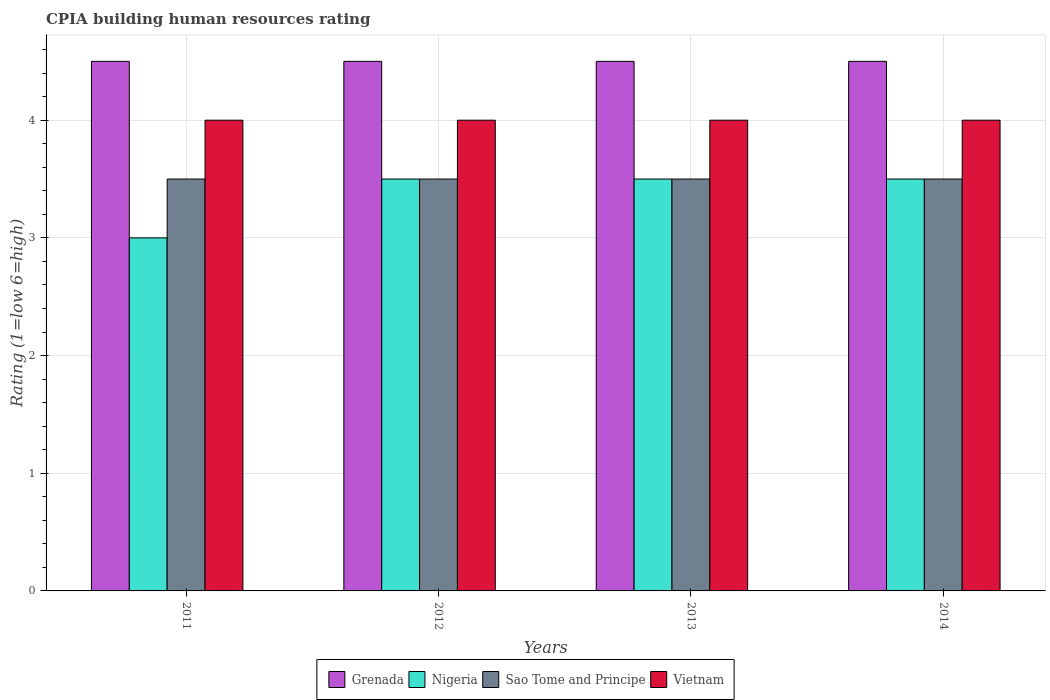Are the number of bars per tick equal to the number of legend labels?
Make the answer very short. Yes. Are the number of bars on each tick of the X-axis equal?
Keep it short and to the point. Yes. How many bars are there on the 3rd tick from the right?
Offer a terse response. 4. What is the label of the 4th group of bars from the left?
Offer a very short reply. 2014. Across all years, what is the maximum CPIA rating in Nigeria?
Your answer should be very brief. 3.5. Across all years, what is the minimum CPIA rating in Nigeria?
Your answer should be compact. 3. In which year was the CPIA rating in Vietnam minimum?
Offer a terse response. 2011. What is the total CPIA rating in Vietnam in the graph?
Keep it short and to the point. 16. What is the difference between the CPIA rating in Nigeria in 2011 and that in 2013?
Your response must be concise. -0.5. What is the difference between the CPIA rating in Vietnam in 2011 and the CPIA rating in Grenada in 2012?
Your answer should be very brief. -0.5. Is the sum of the CPIA rating in Vietnam in 2011 and 2012 greater than the maximum CPIA rating in Grenada across all years?
Give a very brief answer. Yes. Is it the case that in every year, the sum of the CPIA rating in Sao Tome and Principe and CPIA rating in Vietnam is greater than the sum of CPIA rating in Grenada and CPIA rating in Nigeria?
Give a very brief answer. Yes. What does the 2nd bar from the left in 2011 represents?
Keep it short and to the point. Nigeria. What does the 4th bar from the right in 2011 represents?
Offer a very short reply. Grenada. Is it the case that in every year, the sum of the CPIA rating in Sao Tome and Principe and CPIA rating in Nigeria is greater than the CPIA rating in Vietnam?
Offer a very short reply. Yes. How many years are there in the graph?
Your response must be concise. 4. What is the difference between two consecutive major ticks on the Y-axis?
Your answer should be compact. 1. Are the values on the major ticks of Y-axis written in scientific E-notation?
Make the answer very short. No. Does the graph contain any zero values?
Give a very brief answer. No. Where does the legend appear in the graph?
Provide a short and direct response. Bottom center. How many legend labels are there?
Ensure brevity in your answer.  4. What is the title of the graph?
Give a very brief answer. CPIA building human resources rating. Does "Rwanda" appear as one of the legend labels in the graph?
Provide a short and direct response. No. What is the Rating (1=low 6=high) of Vietnam in 2011?
Make the answer very short. 4. What is the Rating (1=low 6=high) of Grenada in 2012?
Your answer should be compact. 4.5. What is the Rating (1=low 6=high) of Nigeria in 2012?
Ensure brevity in your answer.  3.5. What is the Rating (1=low 6=high) of Sao Tome and Principe in 2012?
Provide a short and direct response. 3.5. What is the Rating (1=low 6=high) of Vietnam in 2012?
Keep it short and to the point. 4. What is the Rating (1=low 6=high) in Nigeria in 2013?
Keep it short and to the point. 3.5. What is the Rating (1=low 6=high) in Sao Tome and Principe in 2013?
Keep it short and to the point. 3.5. What is the Rating (1=low 6=high) in Grenada in 2014?
Ensure brevity in your answer.  4.5. What is the Rating (1=low 6=high) in Nigeria in 2014?
Provide a succinct answer. 3.5. What is the Rating (1=low 6=high) in Vietnam in 2014?
Your answer should be compact. 4. Across all years, what is the maximum Rating (1=low 6=high) in Grenada?
Your answer should be very brief. 4.5. Across all years, what is the maximum Rating (1=low 6=high) of Sao Tome and Principe?
Give a very brief answer. 3.5. Across all years, what is the maximum Rating (1=low 6=high) in Vietnam?
Your answer should be very brief. 4. Across all years, what is the minimum Rating (1=low 6=high) in Grenada?
Offer a very short reply. 4.5. Across all years, what is the minimum Rating (1=low 6=high) of Nigeria?
Make the answer very short. 3. Across all years, what is the minimum Rating (1=low 6=high) in Sao Tome and Principe?
Your answer should be very brief. 3.5. Across all years, what is the minimum Rating (1=low 6=high) of Vietnam?
Your response must be concise. 4. What is the total Rating (1=low 6=high) in Grenada in the graph?
Make the answer very short. 18. What is the total Rating (1=low 6=high) in Sao Tome and Principe in the graph?
Offer a terse response. 14. What is the total Rating (1=low 6=high) in Vietnam in the graph?
Make the answer very short. 16. What is the difference between the Rating (1=low 6=high) in Grenada in 2011 and that in 2012?
Make the answer very short. 0. What is the difference between the Rating (1=low 6=high) in Nigeria in 2011 and that in 2012?
Your answer should be very brief. -0.5. What is the difference between the Rating (1=low 6=high) of Sao Tome and Principe in 2011 and that in 2012?
Give a very brief answer. 0. What is the difference between the Rating (1=low 6=high) of Grenada in 2011 and that in 2013?
Make the answer very short. 0. What is the difference between the Rating (1=low 6=high) of Nigeria in 2011 and that in 2013?
Ensure brevity in your answer.  -0.5. What is the difference between the Rating (1=low 6=high) of Grenada in 2011 and that in 2014?
Offer a terse response. 0. What is the difference between the Rating (1=low 6=high) of Sao Tome and Principe in 2011 and that in 2014?
Your answer should be very brief. 0. What is the difference between the Rating (1=low 6=high) in Grenada in 2012 and that in 2013?
Keep it short and to the point. 0. What is the difference between the Rating (1=low 6=high) of Nigeria in 2012 and that in 2014?
Ensure brevity in your answer.  0. What is the difference between the Rating (1=low 6=high) in Vietnam in 2013 and that in 2014?
Your response must be concise. 0. What is the difference between the Rating (1=low 6=high) in Grenada in 2011 and the Rating (1=low 6=high) in Nigeria in 2012?
Your answer should be compact. 1. What is the difference between the Rating (1=low 6=high) of Grenada in 2011 and the Rating (1=low 6=high) of Sao Tome and Principe in 2012?
Offer a very short reply. 1. What is the difference between the Rating (1=low 6=high) of Grenada in 2011 and the Rating (1=low 6=high) of Vietnam in 2012?
Give a very brief answer. 0.5. What is the difference between the Rating (1=low 6=high) of Nigeria in 2011 and the Rating (1=low 6=high) of Sao Tome and Principe in 2012?
Offer a very short reply. -0.5. What is the difference between the Rating (1=low 6=high) of Nigeria in 2011 and the Rating (1=low 6=high) of Vietnam in 2012?
Make the answer very short. -1. What is the difference between the Rating (1=low 6=high) in Grenada in 2011 and the Rating (1=low 6=high) in Vietnam in 2013?
Provide a succinct answer. 0.5. What is the difference between the Rating (1=low 6=high) in Grenada in 2011 and the Rating (1=low 6=high) in Sao Tome and Principe in 2014?
Offer a very short reply. 1. What is the difference between the Rating (1=low 6=high) in Nigeria in 2011 and the Rating (1=low 6=high) in Sao Tome and Principe in 2014?
Provide a short and direct response. -0.5. What is the difference between the Rating (1=low 6=high) in Nigeria in 2011 and the Rating (1=low 6=high) in Vietnam in 2014?
Provide a short and direct response. -1. What is the difference between the Rating (1=low 6=high) in Grenada in 2012 and the Rating (1=low 6=high) in Nigeria in 2013?
Make the answer very short. 1. What is the difference between the Rating (1=low 6=high) of Nigeria in 2012 and the Rating (1=low 6=high) of Vietnam in 2013?
Keep it short and to the point. -0.5. What is the difference between the Rating (1=low 6=high) of Sao Tome and Principe in 2012 and the Rating (1=low 6=high) of Vietnam in 2013?
Your answer should be very brief. -0.5. What is the difference between the Rating (1=low 6=high) of Grenada in 2012 and the Rating (1=low 6=high) of Sao Tome and Principe in 2014?
Your answer should be compact. 1. What is the difference between the Rating (1=low 6=high) of Nigeria in 2012 and the Rating (1=low 6=high) of Sao Tome and Principe in 2014?
Provide a short and direct response. 0. What is the difference between the Rating (1=low 6=high) of Nigeria in 2012 and the Rating (1=low 6=high) of Vietnam in 2014?
Give a very brief answer. -0.5. What is the difference between the Rating (1=low 6=high) in Sao Tome and Principe in 2012 and the Rating (1=low 6=high) in Vietnam in 2014?
Offer a very short reply. -0.5. What is the difference between the Rating (1=low 6=high) in Grenada in 2013 and the Rating (1=low 6=high) in Nigeria in 2014?
Give a very brief answer. 1. What is the difference between the Rating (1=low 6=high) in Grenada in 2013 and the Rating (1=low 6=high) in Sao Tome and Principe in 2014?
Your answer should be very brief. 1. What is the difference between the Rating (1=low 6=high) of Grenada in 2013 and the Rating (1=low 6=high) of Vietnam in 2014?
Provide a succinct answer. 0.5. What is the difference between the Rating (1=low 6=high) of Sao Tome and Principe in 2013 and the Rating (1=low 6=high) of Vietnam in 2014?
Offer a very short reply. -0.5. What is the average Rating (1=low 6=high) of Grenada per year?
Provide a short and direct response. 4.5. What is the average Rating (1=low 6=high) of Nigeria per year?
Offer a terse response. 3.38. What is the average Rating (1=low 6=high) in Sao Tome and Principe per year?
Offer a very short reply. 3.5. What is the average Rating (1=low 6=high) of Vietnam per year?
Offer a terse response. 4. In the year 2011, what is the difference between the Rating (1=low 6=high) in Grenada and Rating (1=low 6=high) in Vietnam?
Your answer should be compact. 0.5. In the year 2011, what is the difference between the Rating (1=low 6=high) of Sao Tome and Principe and Rating (1=low 6=high) of Vietnam?
Your response must be concise. -0.5. In the year 2012, what is the difference between the Rating (1=low 6=high) in Grenada and Rating (1=low 6=high) in Sao Tome and Principe?
Ensure brevity in your answer.  1. In the year 2012, what is the difference between the Rating (1=low 6=high) in Nigeria and Rating (1=low 6=high) in Sao Tome and Principe?
Provide a short and direct response. 0. In the year 2012, what is the difference between the Rating (1=low 6=high) in Sao Tome and Principe and Rating (1=low 6=high) in Vietnam?
Your response must be concise. -0.5. In the year 2013, what is the difference between the Rating (1=low 6=high) in Grenada and Rating (1=low 6=high) in Sao Tome and Principe?
Provide a short and direct response. 1. In the year 2013, what is the difference between the Rating (1=low 6=high) in Grenada and Rating (1=low 6=high) in Vietnam?
Ensure brevity in your answer.  0.5. In the year 2013, what is the difference between the Rating (1=low 6=high) in Nigeria and Rating (1=low 6=high) in Sao Tome and Principe?
Provide a succinct answer. 0. In the year 2013, what is the difference between the Rating (1=low 6=high) in Nigeria and Rating (1=low 6=high) in Vietnam?
Offer a very short reply. -0.5. In the year 2013, what is the difference between the Rating (1=low 6=high) of Sao Tome and Principe and Rating (1=low 6=high) of Vietnam?
Keep it short and to the point. -0.5. In the year 2014, what is the difference between the Rating (1=low 6=high) of Grenada and Rating (1=low 6=high) of Vietnam?
Ensure brevity in your answer.  0.5. In the year 2014, what is the difference between the Rating (1=low 6=high) in Nigeria and Rating (1=low 6=high) in Sao Tome and Principe?
Your answer should be compact. 0. In the year 2014, what is the difference between the Rating (1=low 6=high) in Nigeria and Rating (1=low 6=high) in Vietnam?
Your response must be concise. -0.5. In the year 2014, what is the difference between the Rating (1=low 6=high) of Sao Tome and Principe and Rating (1=low 6=high) of Vietnam?
Give a very brief answer. -0.5. What is the ratio of the Rating (1=low 6=high) in Grenada in 2011 to that in 2012?
Keep it short and to the point. 1. What is the ratio of the Rating (1=low 6=high) in Sao Tome and Principe in 2011 to that in 2012?
Keep it short and to the point. 1. What is the ratio of the Rating (1=low 6=high) of Vietnam in 2011 to that in 2012?
Provide a short and direct response. 1. What is the ratio of the Rating (1=low 6=high) in Nigeria in 2011 to that in 2013?
Give a very brief answer. 0.86. What is the ratio of the Rating (1=low 6=high) in Sao Tome and Principe in 2011 to that in 2013?
Give a very brief answer. 1. What is the ratio of the Rating (1=low 6=high) in Grenada in 2011 to that in 2014?
Offer a very short reply. 1. What is the ratio of the Rating (1=low 6=high) in Nigeria in 2011 to that in 2014?
Your answer should be compact. 0.86. What is the ratio of the Rating (1=low 6=high) of Sao Tome and Principe in 2011 to that in 2014?
Provide a succinct answer. 1. What is the ratio of the Rating (1=low 6=high) in Grenada in 2012 to that in 2013?
Your answer should be very brief. 1. What is the ratio of the Rating (1=low 6=high) of Vietnam in 2012 to that in 2013?
Keep it short and to the point. 1. What is the ratio of the Rating (1=low 6=high) of Vietnam in 2013 to that in 2014?
Keep it short and to the point. 1. What is the difference between the highest and the second highest Rating (1=low 6=high) of Grenada?
Give a very brief answer. 0. What is the difference between the highest and the second highest Rating (1=low 6=high) in Sao Tome and Principe?
Make the answer very short. 0. What is the difference between the highest and the lowest Rating (1=low 6=high) of Grenada?
Your answer should be compact. 0. What is the difference between the highest and the lowest Rating (1=low 6=high) in Sao Tome and Principe?
Ensure brevity in your answer.  0. What is the difference between the highest and the lowest Rating (1=low 6=high) of Vietnam?
Provide a succinct answer. 0. 